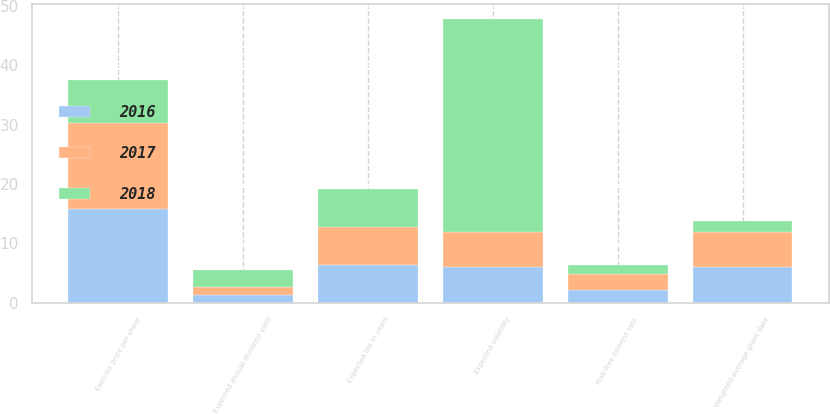Convert chart. <chart><loc_0><loc_0><loc_500><loc_500><stacked_bar_chart><ecel><fcel>Exercise price per share<fcel>Expected annual dividend yield<fcel>Expected life in years<fcel>Expected volatility<fcel>Risk-free interest rate<fcel>Weighted average grant date<nl><fcel>2017<fcel>14.52<fcel>1.4<fcel>6.45<fcel>5.95<fcel>2.8<fcel>5.83<nl><fcel>2016<fcel>15.8<fcel>1.3<fcel>6.4<fcel>5.95<fcel>2.1<fcel>6.07<nl><fcel>2018<fcel>7.22<fcel>2.8<fcel>6.3<fcel>36<fcel>1.4<fcel>1.97<nl></chart> 